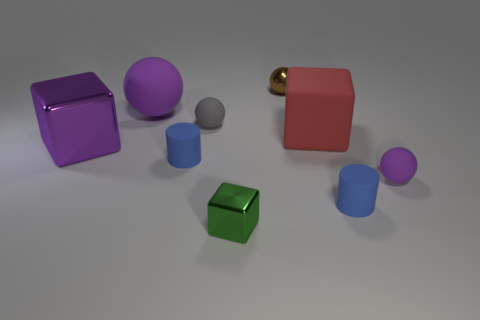Subtract all shiny spheres. How many spheres are left? 3 Subtract all purple spheres. How many spheres are left? 2 Subtract 2 cylinders. How many cylinders are left? 0 Subtract all cylinders. How many objects are left? 7 Add 6 purple rubber spheres. How many purple rubber spheres are left? 8 Add 1 large blue rubber objects. How many large blue rubber objects exist? 1 Subtract 0 cyan cubes. How many objects are left? 9 Subtract all green blocks. Subtract all green cylinders. How many blocks are left? 2 Subtract all blue cylinders. How many blue spheres are left? 0 Subtract all large rubber cubes. Subtract all small blue matte cylinders. How many objects are left? 6 